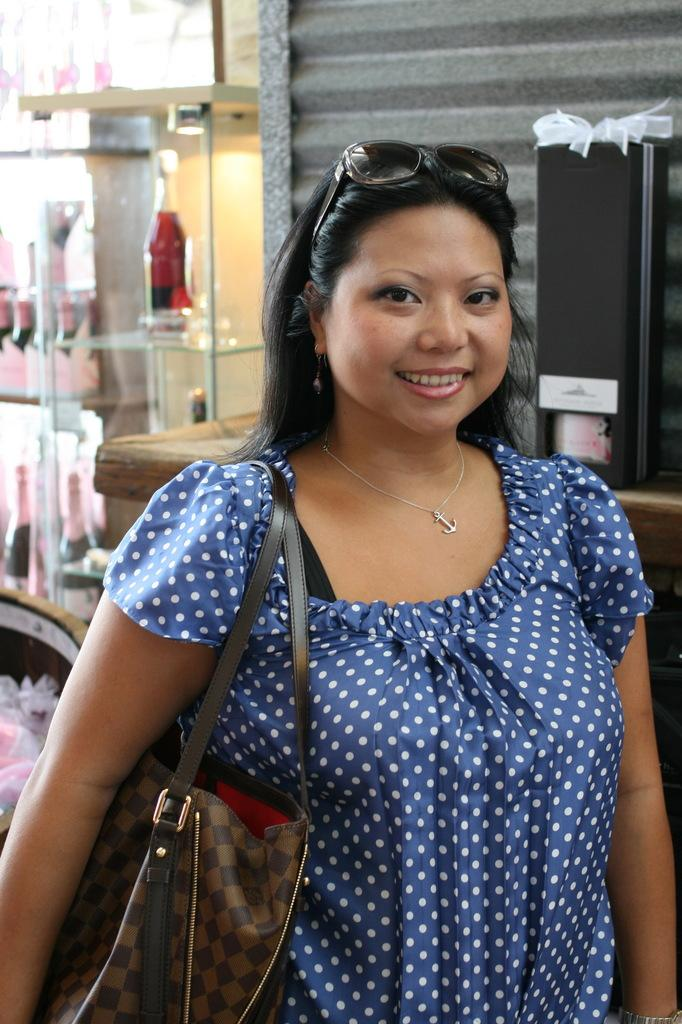Who is present in the image? There is a woman in the image. What is the woman doing in the image? The woman is standing. What can be seen on the woman's face in the image? The woman is wearing big glasses. What is visible in the background of the image? There is a glass shelf and a wall in the background of the image. What is placed on the glass shelf? There is a bottle on the glass shelf. How many people are resting on the wall in the image? There are no people resting on the wall in the image. What type of hair can be seen on the woman's head in the image? The image does not show the woman's hair, as it only focuses on her face and glasses. 